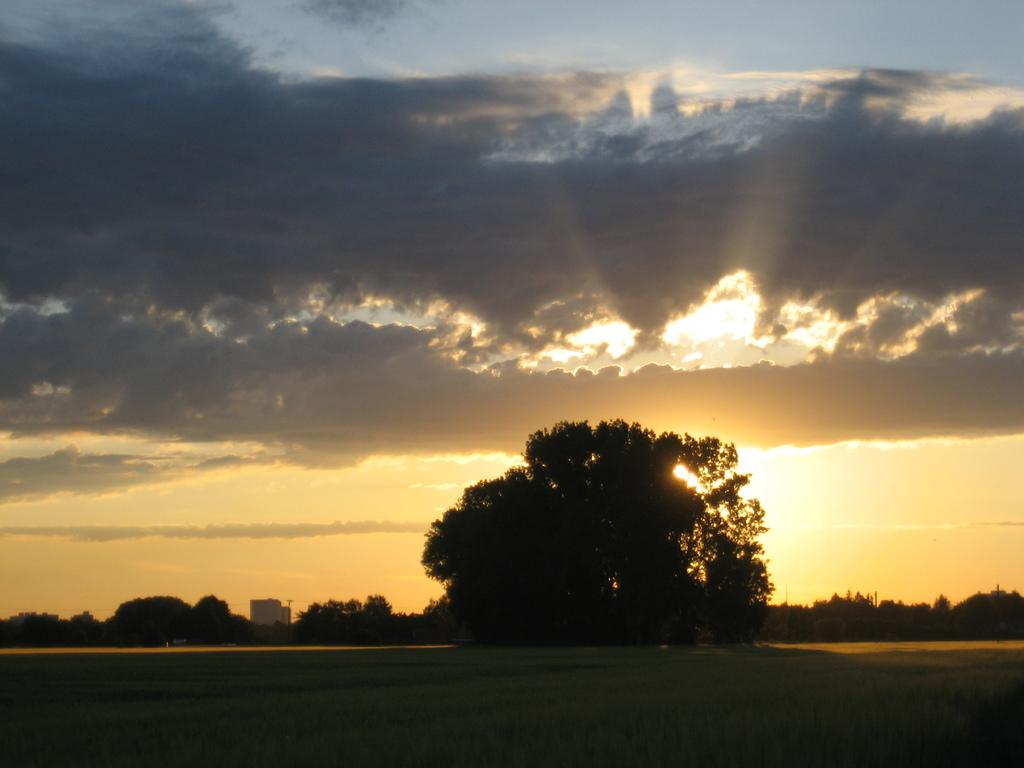What can be seen at the bottom of the image? The ground is visible in the image. What type of vegetation is in the background of the image? There are trees in the background of the image. What else can be seen in the background of the image? The sky is visible in the background of the image. What is the condition of the sky in the image? Clouds are present in the sky. What type of behavior can be observed in the downtown area in the image? There is no downtown area present in the image, and therefore no behavior can be observed. 